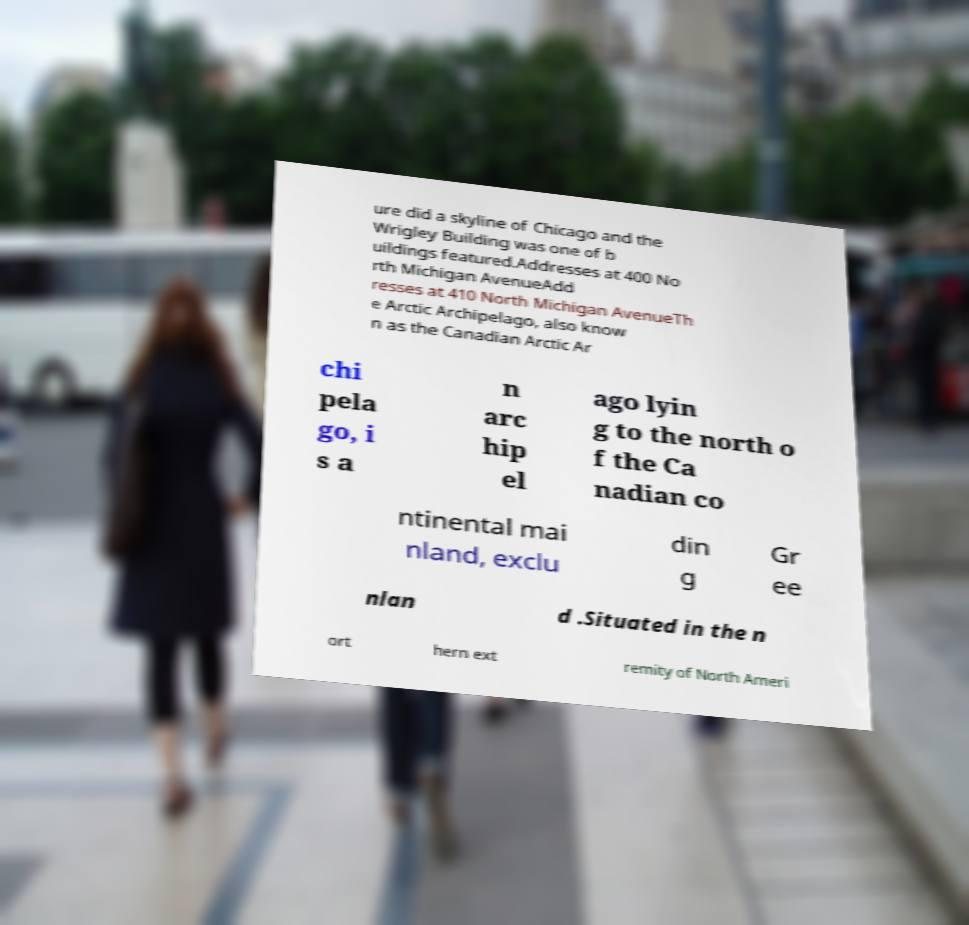I need the written content from this picture converted into text. Can you do that? ure did a skyline of Chicago and the Wrigley Building was one of b uildings featured.Addresses at 400 No rth Michigan AvenueAdd resses at 410 North Michigan AvenueTh e Arctic Archipelago, also know n as the Canadian Arctic Ar chi pela go, i s a n arc hip el ago lyin g to the north o f the Ca nadian co ntinental mai nland, exclu din g Gr ee nlan d .Situated in the n ort hern ext remity of North Ameri 